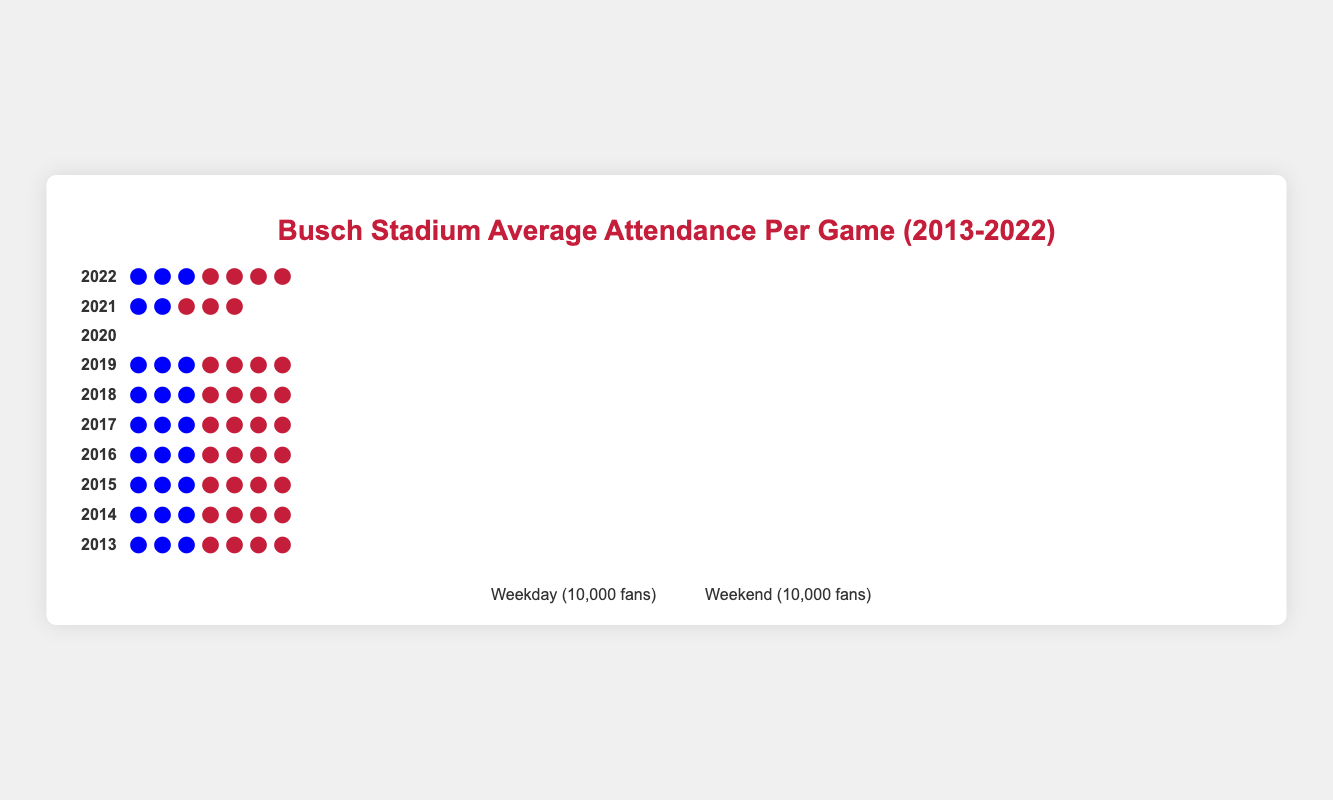What is the average weekday attendance in 2018? The Isotype Plot shows that the weekday attendance in 2018 was represented by three blue icons, each representing 10,000 fans. This means the average weekday attendance was 3 * 10,000 fans.
Answer: 34,500 How did the weekend attendance in 2015 compare to the weekday attendance in the same year? The Isotype Plot shows that the weekend attendance in 2015 was represented by four red icons (each 10,000 fans), totaling 44,000 fans. The weekday attendance was three blue icons (each 10,000 fans), totaling 37,000 fans. Therefore, the weekend attendance was greater than the weekday attendance by 44,000 - 37,000 = 7,000 fans.
Answer: 7,000 fans What was the trend in weekend attendance from 2015 to 2017? The Isotype Plot shows that weekend attendance was represented by four red icons, each representing 10,000 fans, in each year from 2015 to 2017. The figures were: 44,000 in 2015, 43,000 in 2016, and 42,500 in 2017. Therefore, weekend attendance decreased during this period.
Answer: Decreasing Which year had the highest average weekend attendance? The Isotype Plot shows that the highest number of red icons (each representing 10,000 fans) in any given year appeared in 2015, where there were four icons representing 44,000 fans.
Answer: 2015 How did attendance change in 2020 compared to other years? The Isotype Plot shows that there were no icons representing either weekday or weekend attendance in 2020, indicating no fans attended due to the pandemic. In other years, there are icons representing 10,000 fans each for weekday and weekend attendance.
Answer: There was no attendance in 2020 due to the pandemic What’s the difference between weekday and weekend attendance in 2022? In 2022, the Isotype Plot shows three blue icons for weekday attendance (each 10,000 fans), totaling 33,000 fans, and four red icons for weekend attendance (each 10,000 fans), totaling 40,000 fans. Therefore, the difference is 40,000 - 33,000 = 7,000 fans.
Answer: 7,000 fans What is the overall trend in weekday attendance from 2013 to 2022? The Isotype Plot shows that weekday attendance generally decreased over the years with a few minor fluctuations. For example, it started with three blue icons in 2013 and settled at three again in 2022, with the change mostly summarized by the fact that one icon means fewer fans in some years.
Answer: Decreasing Which year showed the most significant drop in attendance from the previous year? Noticeably, 2021 had a significant drop in attendance from the previous year since 2020 had no attendance due to the pandemic, and the attendance in subsequent years drastically illustrates this drop, especially starting 25,000 for weekdays in 2021.
Answer: 2021 What was the average attendance (combining weekdays and weekends) in 2017? The Isotype Plot shows that weekday attendance in 2017 was three blue icons (each 10,000 fans), totaling 35,500 fans, and the weekend attendance was four red icons, totaling 42,500 fans. The average attendance combining weekdays and weekends is (35,500 + 42,500) / 2.
Answer: 39,000 fans How did attendance recover in 2021 after the drop in 2020? In 2021, the Isotype Plot shows that weekday attendance was two blue icons (each 10,000 fans), totaling 25,000 fans, and weekend attendance was three red icons (each 10,000 fans), totaling 32,000 fans. This indicates a recovery from the complete lack of attendance in 2020 to partial attendance in 2021.
Answer: Partial recovery 